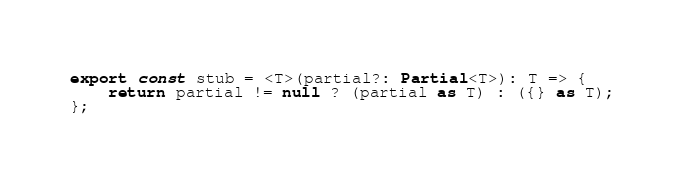Convert code to text. <code><loc_0><loc_0><loc_500><loc_500><_TypeScript_>export const stub = <T>(partial?: Partial<T>): T => {
    return partial != null ? (partial as T) : ({} as T);
};
</code> 